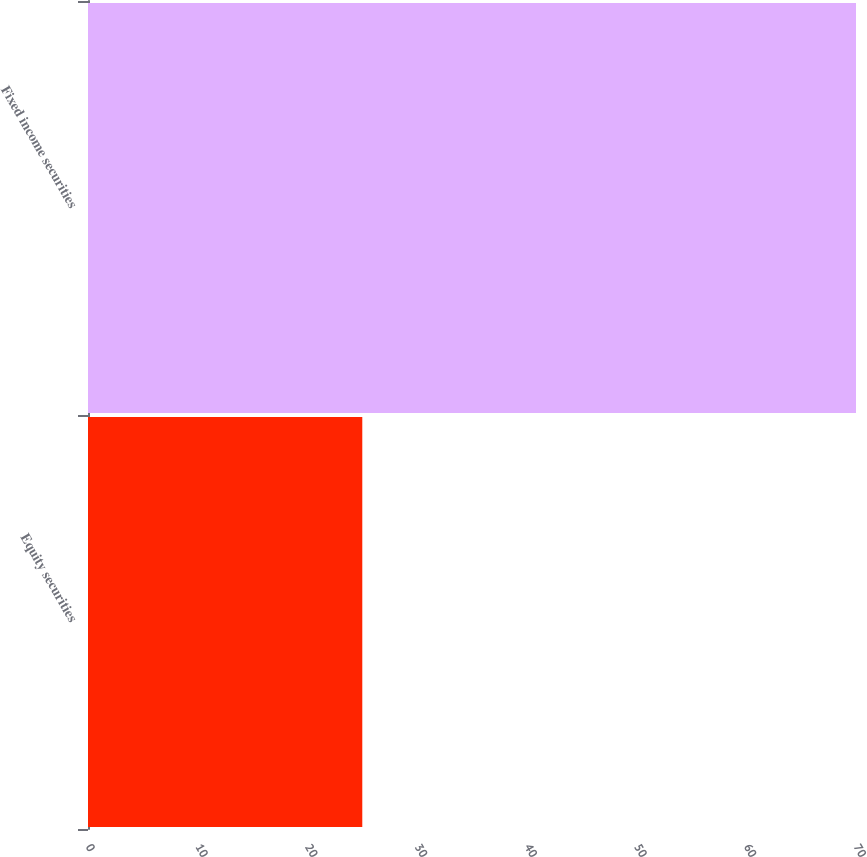Convert chart to OTSL. <chart><loc_0><loc_0><loc_500><loc_500><bar_chart><fcel>Equity securities<fcel>Fixed income securities<nl><fcel>25<fcel>70<nl></chart> 